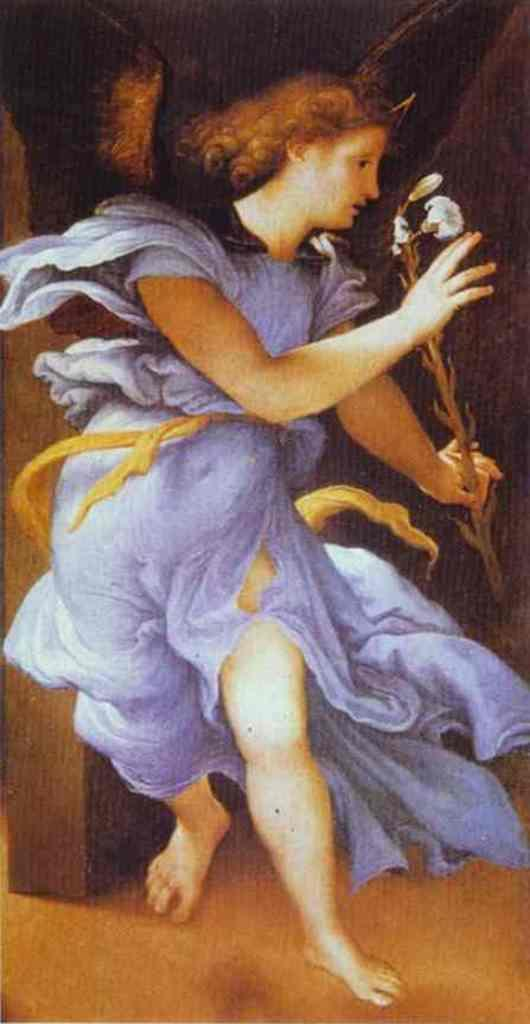What is the main subject of the image? The image contains an art piece. What does the art piece depict? The art piece depicts a woman. What is the woman wearing in the art piece? The woman is wearing a blue dress. What is the woman holding in the art piece? The woman is holding a flower in her hand. What decision does the woman make in the art piece? There is no indication in the image that the woman is making a decision, as the art piece only shows her wearing a blue dress and holding a flower. 